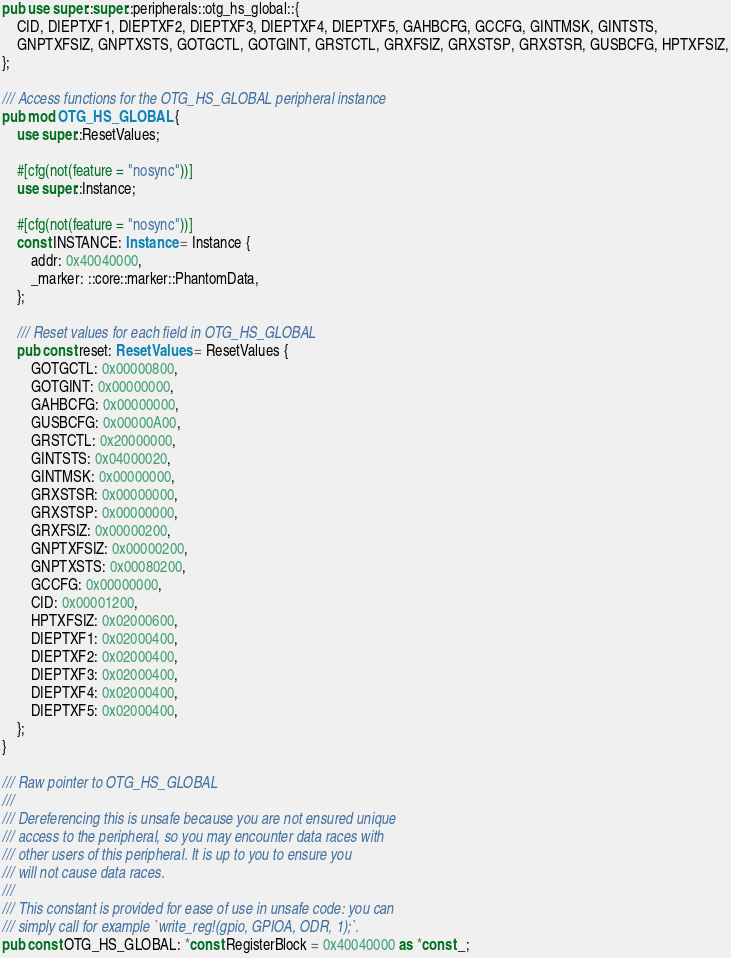<code> <loc_0><loc_0><loc_500><loc_500><_Rust_>pub use super::super::peripherals::otg_hs_global::{
    CID, DIEPTXF1, DIEPTXF2, DIEPTXF3, DIEPTXF4, DIEPTXF5, GAHBCFG, GCCFG, GINTMSK, GINTSTS,
    GNPTXFSIZ, GNPTXSTS, GOTGCTL, GOTGINT, GRSTCTL, GRXFSIZ, GRXSTSP, GRXSTSR, GUSBCFG, HPTXFSIZ,
};

/// Access functions for the OTG_HS_GLOBAL peripheral instance
pub mod OTG_HS_GLOBAL {
    use super::ResetValues;

    #[cfg(not(feature = "nosync"))]
    use super::Instance;

    #[cfg(not(feature = "nosync"))]
    const INSTANCE: Instance = Instance {
        addr: 0x40040000,
        _marker: ::core::marker::PhantomData,
    };

    /// Reset values for each field in OTG_HS_GLOBAL
    pub const reset: ResetValues = ResetValues {
        GOTGCTL: 0x00000800,
        GOTGINT: 0x00000000,
        GAHBCFG: 0x00000000,
        GUSBCFG: 0x00000A00,
        GRSTCTL: 0x20000000,
        GINTSTS: 0x04000020,
        GINTMSK: 0x00000000,
        GRXSTSR: 0x00000000,
        GRXSTSP: 0x00000000,
        GRXFSIZ: 0x00000200,
        GNPTXFSIZ: 0x00000200,
        GNPTXSTS: 0x00080200,
        GCCFG: 0x00000000,
        CID: 0x00001200,
        HPTXFSIZ: 0x02000600,
        DIEPTXF1: 0x02000400,
        DIEPTXF2: 0x02000400,
        DIEPTXF3: 0x02000400,
        DIEPTXF4: 0x02000400,
        DIEPTXF5: 0x02000400,
    };
}

/// Raw pointer to OTG_HS_GLOBAL
///
/// Dereferencing this is unsafe because you are not ensured unique
/// access to the peripheral, so you may encounter data races with
/// other users of this peripheral. It is up to you to ensure you
/// will not cause data races.
///
/// This constant is provided for ease of use in unsafe code: you can
/// simply call for example `write_reg!(gpio, GPIOA, ODR, 1);`.
pub const OTG_HS_GLOBAL: *const RegisterBlock = 0x40040000 as *const _;
</code> 